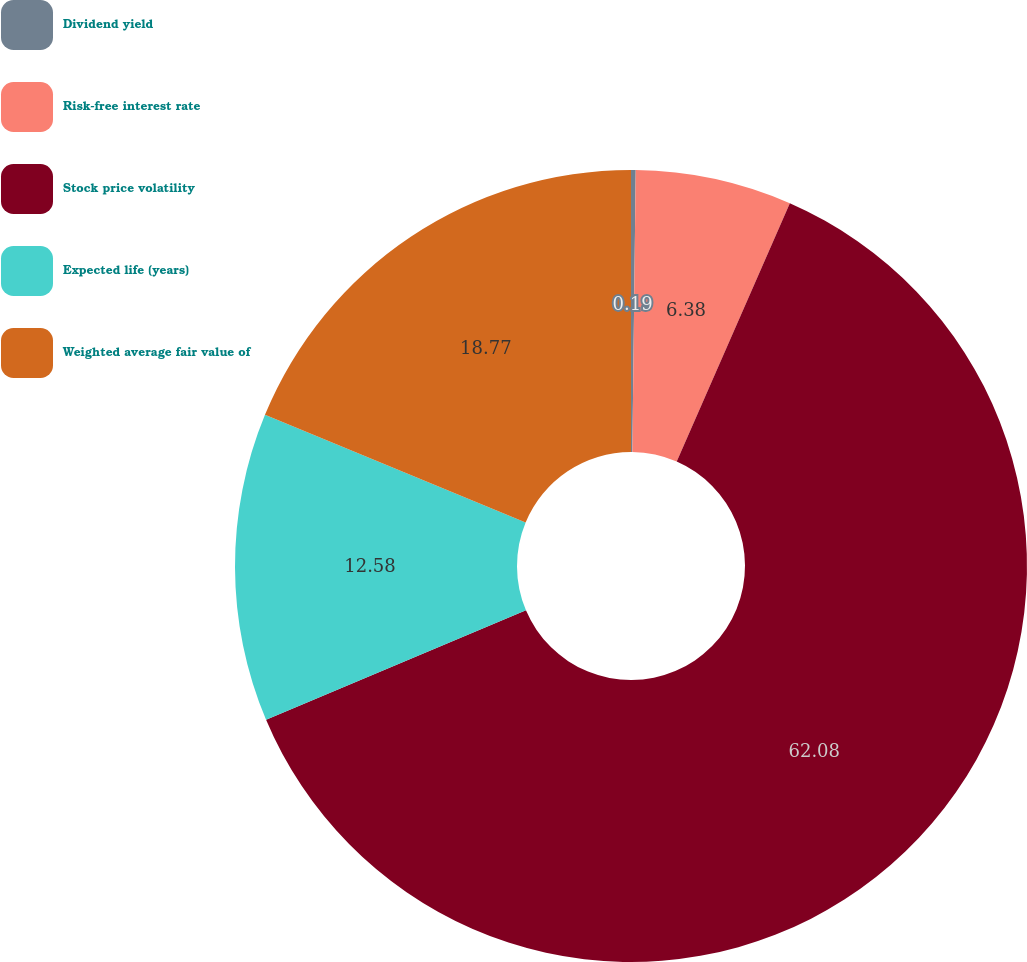Convert chart to OTSL. <chart><loc_0><loc_0><loc_500><loc_500><pie_chart><fcel>Dividend yield<fcel>Risk-free interest rate<fcel>Stock price volatility<fcel>Expected life (years)<fcel>Weighted average fair value of<nl><fcel>0.19%<fcel>6.38%<fcel>62.09%<fcel>12.58%<fcel>18.77%<nl></chart> 